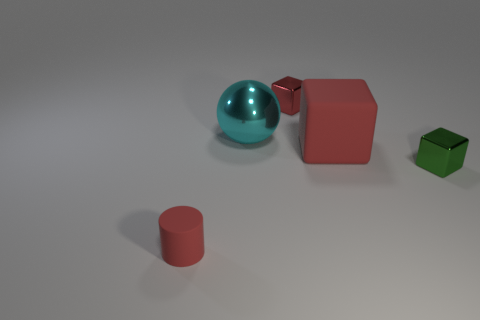What is the size of the red rubber thing that is the same shape as the tiny green metal object?
Your answer should be very brief. Large. Is the tiny cylinder the same color as the big block?
Ensure brevity in your answer.  Yes. Is there anything else that is the same material as the small cylinder?
Make the answer very short. Yes. How big is the red thing in front of the tiny metal object in front of the red matte thing to the right of the big shiny object?
Your answer should be compact. Small. There is a red thing that is in front of the sphere and behind the tiny matte cylinder; what is its size?
Give a very brief answer. Large. There is a small metallic block that is right of the tiny red metallic object; does it have the same color as the metallic cube behind the red matte block?
Keep it short and to the point. No. What number of rubber cylinders are to the left of the red metal block?
Give a very brief answer. 1. Is there a red thing that is in front of the red block to the right of the shiny block that is behind the red matte cube?
Keep it short and to the point. Yes. How many other cubes are the same size as the green metal block?
Provide a succinct answer. 1. The tiny cube that is in front of the rubber thing behind the tiny matte cylinder is made of what material?
Your answer should be very brief. Metal. 